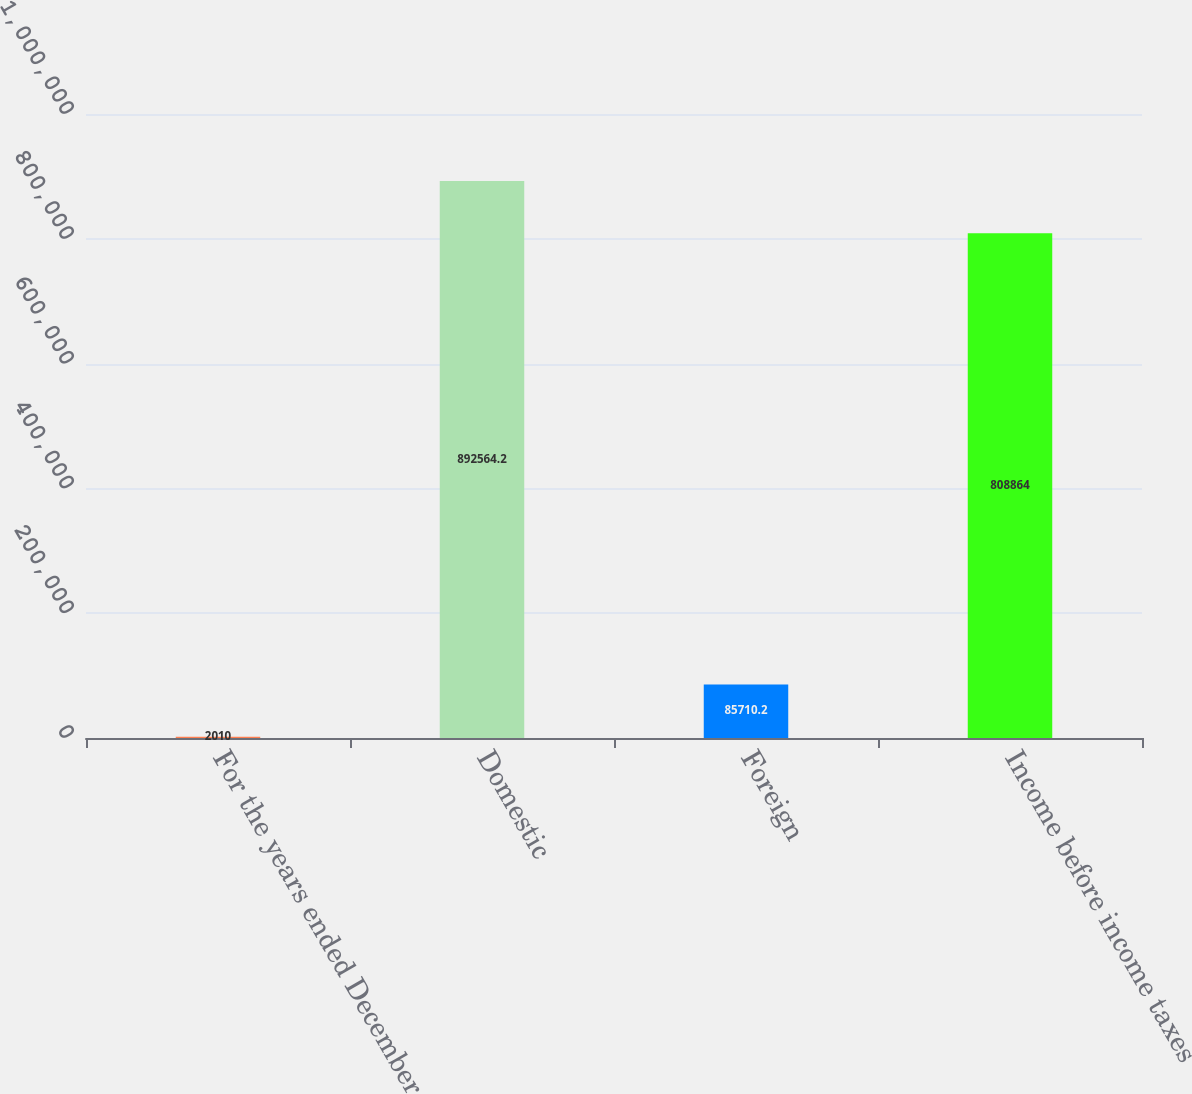Convert chart to OTSL. <chart><loc_0><loc_0><loc_500><loc_500><bar_chart><fcel>For the years ended December<fcel>Domestic<fcel>Foreign<fcel>Income before income taxes<nl><fcel>2010<fcel>892564<fcel>85710.2<fcel>808864<nl></chart> 